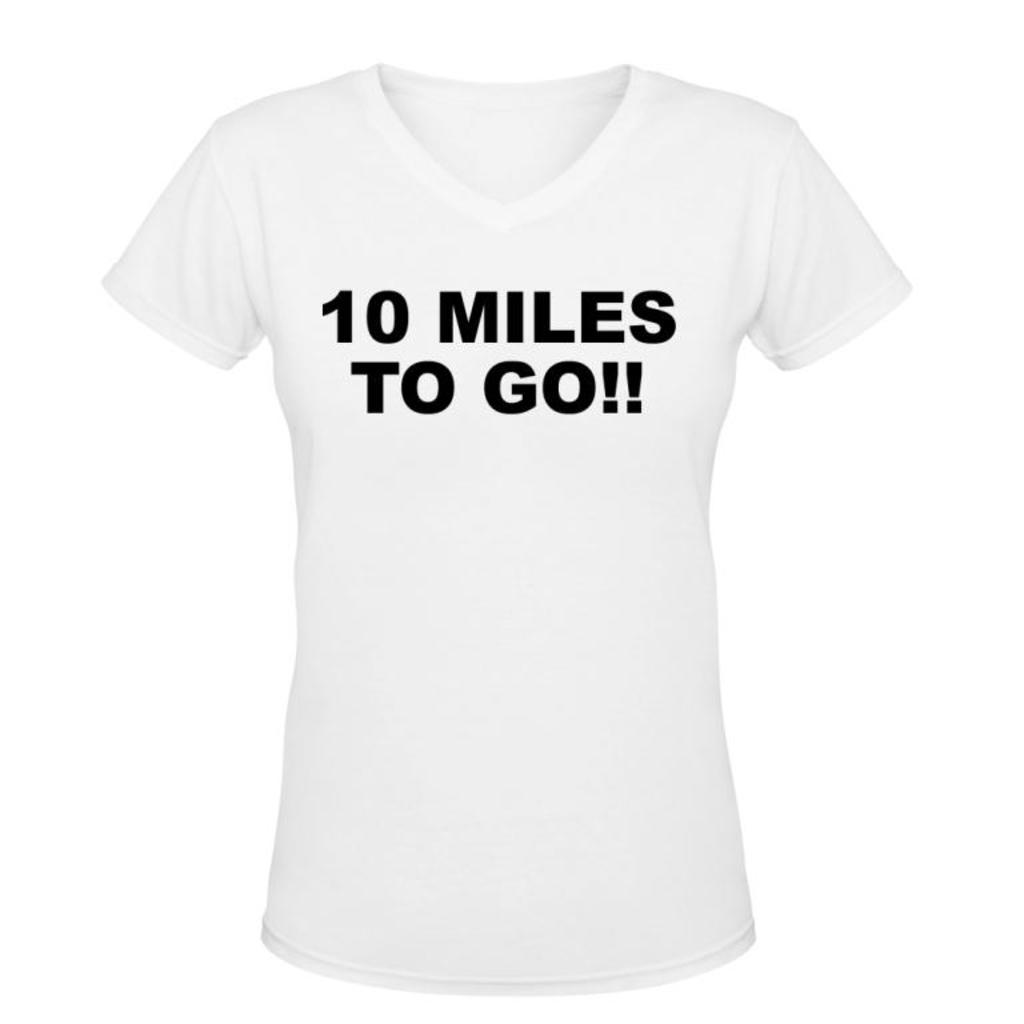What type of clothing item is in the image? There is a white T-shirt in the image. What is written on the T-shirt? The T-shirt has edited text in black color. What is the color of the background in the image? The background of the image is in black color. Can you see a girl kicking a rose in the image? No, there is no girl or rose present in the image. 